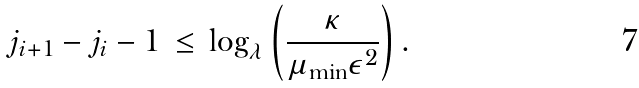Convert formula to latex. <formula><loc_0><loc_0><loc_500><loc_500>j _ { i + 1 } - j _ { i } - 1 \, \leq \, \log _ { \lambda } \left ( \frac { \kappa } { \mu _ { \min } \epsilon ^ { 2 } } \right ) .</formula> 